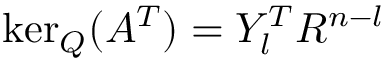Convert formula to latex. <formula><loc_0><loc_0><loc_500><loc_500>\ker _ { Q } ( A ^ { T } ) = Y _ { l } ^ { T } R ^ { n - l }</formula> 